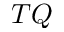<formula> <loc_0><loc_0><loc_500><loc_500>T Q</formula> 